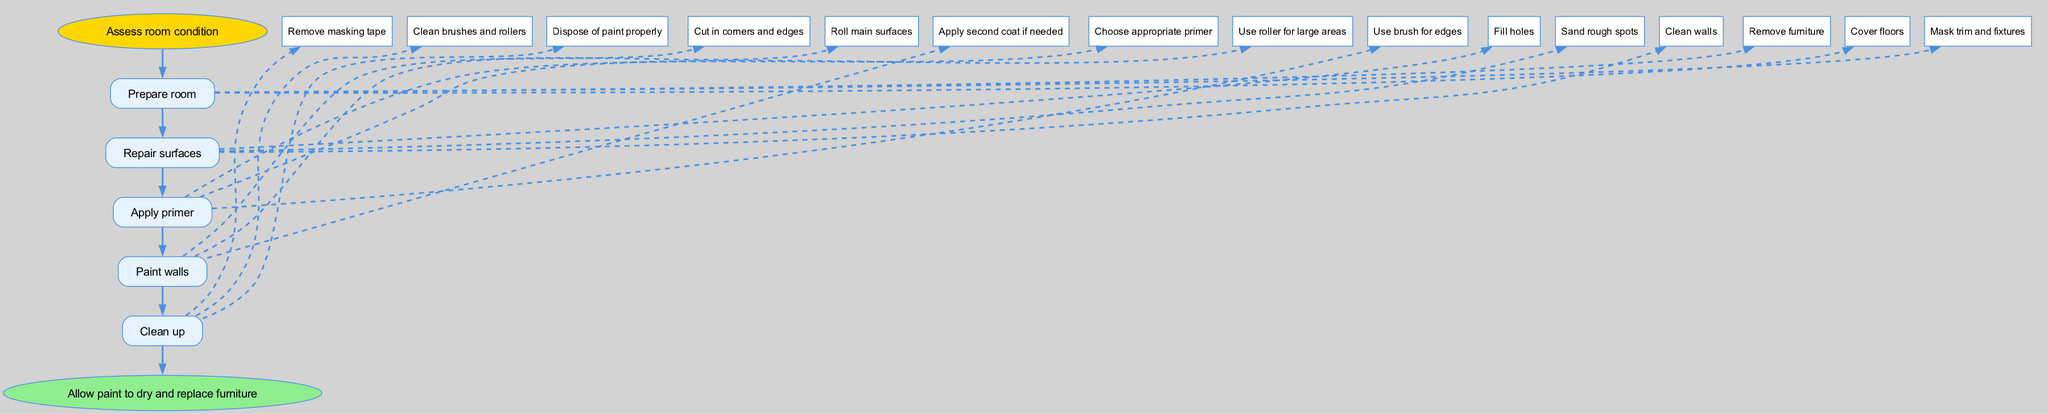What is the first step in the painting process? The diagram indicates that the first step is "Assess room condition." This is the starting point, denoted by the "Start" node, leading to the next step.
Answer: Assess room condition How many steps are involved in the painting process? By examining the diagram, there are a total of five primary steps listed, along with the start and end nodes: Prepare room, Repair surfaces, Apply primer, Paint walls, and Clean up. Counting each of these gives us five steps.
Answer: 5 What do you need to do after "Apply primer"? The arrow from the "Apply primer" node clearly leads to the "Paint walls" node. This indicates that "Paint walls" is the next step to take after applying the primer.
Answer: Paint walls Which node comes after "Repair surfaces"? The flow progresses directly from the "Repair surfaces" node to the "Apply primer" node, demonstrating that applying primer is the action to follow after surface repairs are completed.
Answer: Apply primer What is the last action outlined in the diagram? The final action of the diagram is indicated by the "Clean up" node. According to the flowchart, this step comes before reaching the end, which states to allow the paint to dry and replace furniture.
Answer: Clean up How many edges are connected to the "Prepare room" node? Upon reviewing the "Prepare room" node in the diagram, three edges lead from it, each representing a specific action: "Remove furniture," "Cover floors," and "Mask trim and fixtures."
Answer: 3 What should you do before painting? The step before painting, as per the diagram, is "Apply primer," denoting that primer must be applied prior to the actual painting of the walls.
Answer: Apply primer What is the relationship between "Clean up" and "End"? The diagram shows a direct connection from the "Clean up" step to the "End" node, meaning that cleaning up is the final step to complete before reaching the conclusion of the process.
Answer: Direct connection What is the total number of edges in the diagram? The total number of edges represents the connections between nodes. By counting all edges from each step including the sub-steps, the diagram presents a total of twelve edges connecting the various nodes and actions.
Answer: 12 